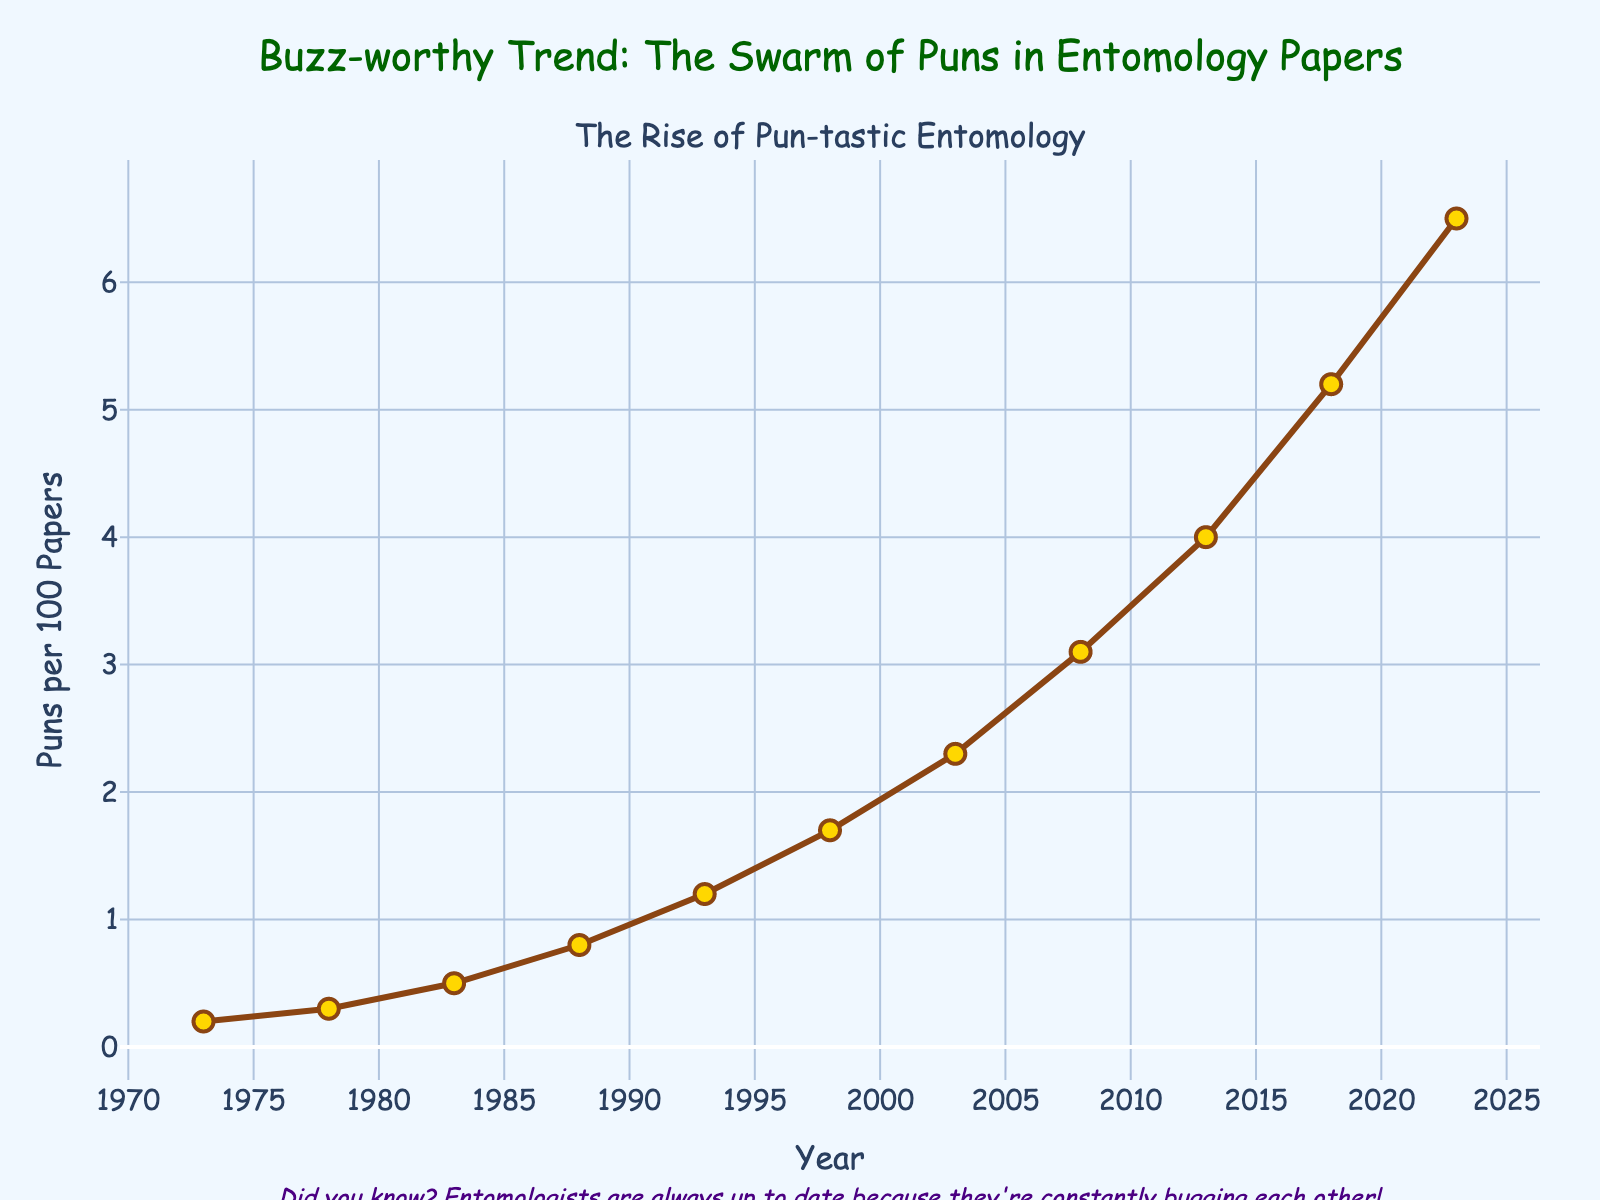What was the frequency of puns in 2018? Look at the data point corresponding to the year 2018 on the x-axis. The y-value at this point is the frequency of puns per 100 papers.
Answer: 5.2 In which year did the frequency of puns first exceed 1 per 100 papers? Identify the first data point where the y-value is greater than 1. This occurs in the year 1993.
Answer: 1993 Between 2008 and 2013, how much did the frequency of puns increase? Find the data points for the years 2008 and 2013. Subtract the frequency in 2008 (3.1) from the frequency in 2013 (4.0).
Answer: 0.9 Which year saw the largest increase in the frequency of puns compared to the previous year? Calculate differences between consecutive years: 
1973-1978: 0.3-0.2 = 0.1 
1978-1983: 0.5-0.3 = 0.2 
1983-1988: 0.8-0.5 = 0.3 
1988-1993: 1.2-0.8 = 0.4 
1993-1998: 1.7-1.2 = 0.5 
1998-2003: 2.3-1.7 = 0.6 
2003-2008: 3.1-2.3 = 0.8 
2008-2013: 4.0-3.1 = 0.9 
2013-2018: 5.2-4.0 = 1.2 
2018-2023: 6.5-5.2 = 1.3 
The largest increase is from 2018 to 2023.
Answer: 2018 to 2023 What is the average frequency of puns per 100 papers over the entire period? Sum the frequencies and divide by the number of years: 
(0.2+0.3+0.5+0.8+1.2+1.7+2.3+3.1+4.0+5.2+6.5) = 25.8
25.8 / 11 = 2.35
Answer: 2.35 How does the frequency of puns in 1998 compare to that in 2003? Check the y-values for 1998 and 2003: 1998 (1.7), 2003 (2.3). 2003 is higher than 1998 by 0.6.
Answer: 2003 was higher by 0.6 Which decade saw the most significant increase in pun frequency? Calculate increases for each decade: 
1973-1983: 0.5-0.2 = 0.3 
1983-1993: 1.2-0.5 = 0.7 
1993-2003: 2.3-1.2 = 1.1 
2003-2013: 4.0-2.3 = 1.7 
2013-2023: 6.5-4.0 = 2.5 
The most significant increase is in the 2013-2023 decade.
Answer: 2013-2023 What is the trend in the frequency of puns from 1973 to 2023? Observe the general direction of the line from 1973 to 2023. The slope is consistently upward, indicating a rising trend.
Answer: Increasing 